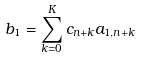Convert formula to latex. <formula><loc_0><loc_0><loc_500><loc_500>b _ { 1 } = \sum _ { k = 0 } ^ { K } c _ { n + k } a _ { 1 , n + k }</formula> 